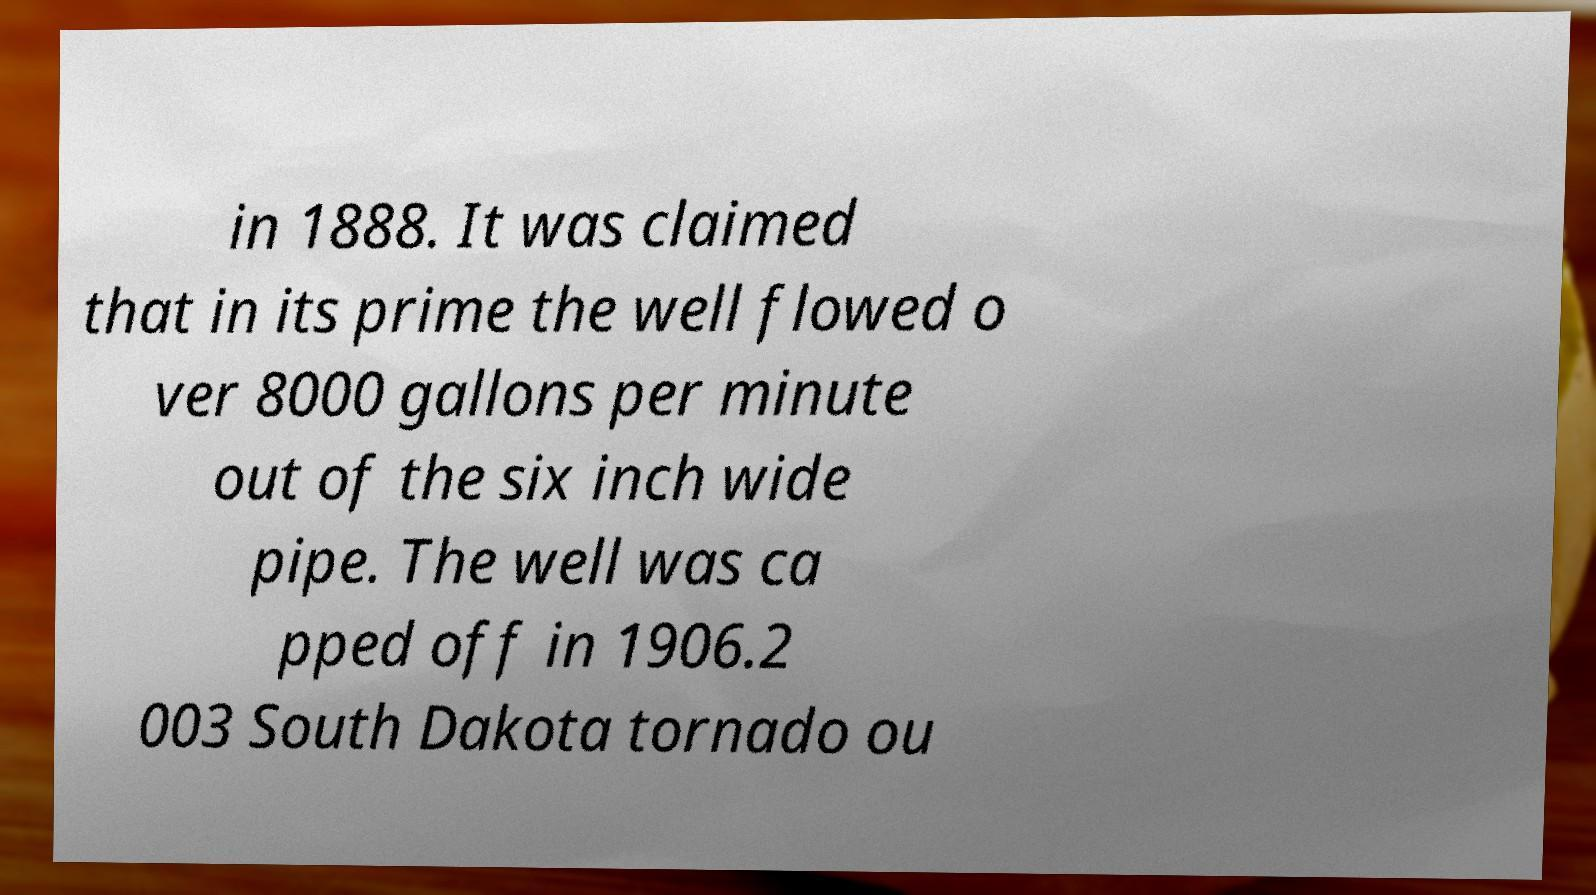I need the written content from this picture converted into text. Can you do that? in 1888. It was claimed that in its prime the well flowed o ver 8000 gallons per minute out of the six inch wide pipe. The well was ca pped off in 1906.2 003 South Dakota tornado ou 